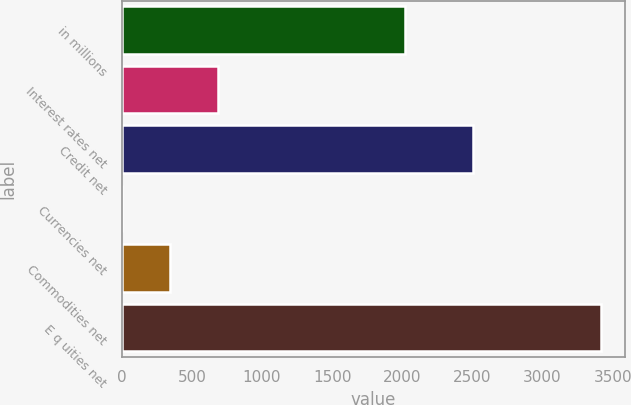Convert chart. <chart><loc_0><loc_0><loc_500><loc_500><bar_chart><fcel>in millions<fcel>Interest rates net<fcel>Credit net<fcel>Currencies net<fcel>Commodities net<fcel>E q uities net<nl><fcel>2016<fcel>685.6<fcel>2504<fcel>3<fcel>344.3<fcel>3416<nl></chart> 